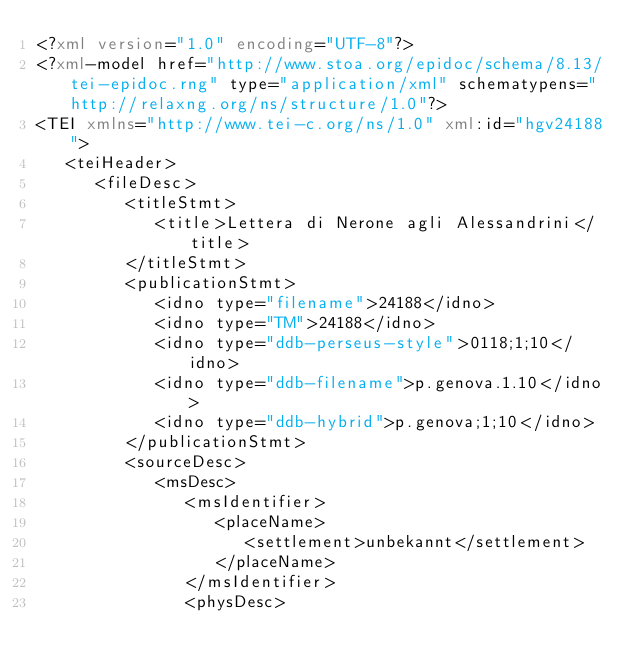Convert code to text. <code><loc_0><loc_0><loc_500><loc_500><_XML_><?xml version="1.0" encoding="UTF-8"?>
<?xml-model href="http://www.stoa.org/epidoc/schema/8.13/tei-epidoc.rng" type="application/xml" schematypens="http://relaxng.org/ns/structure/1.0"?>
<TEI xmlns="http://www.tei-c.org/ns/1.0" xml:id="hgv24188">
   <teiHeader>
      <fileDesc>
         <titleStmt>
            <title>Lettera di Nerone agli Alessandrini</title>
         </titleStmt>
         <publicationStmt>
            <idno type="filename">24188</idno>
            <idno type="TM">24188</idno>
            <idno type="ddb-perseus-style">0118;1;10</idno>
            <idno type="ddb-filename">p.genova.1.10</idno>
            <idno type="ddb-hybrid">p.genova;1;10</idno>
         </publicationStmt>
         <sourceDesc>
            <msDesc>
               <msIdentifier>
                  <placeName>
                     <settlement>unbekannt</settlement>
                  </placeName>
               </msIdentifier>
               <physDesc></code> 